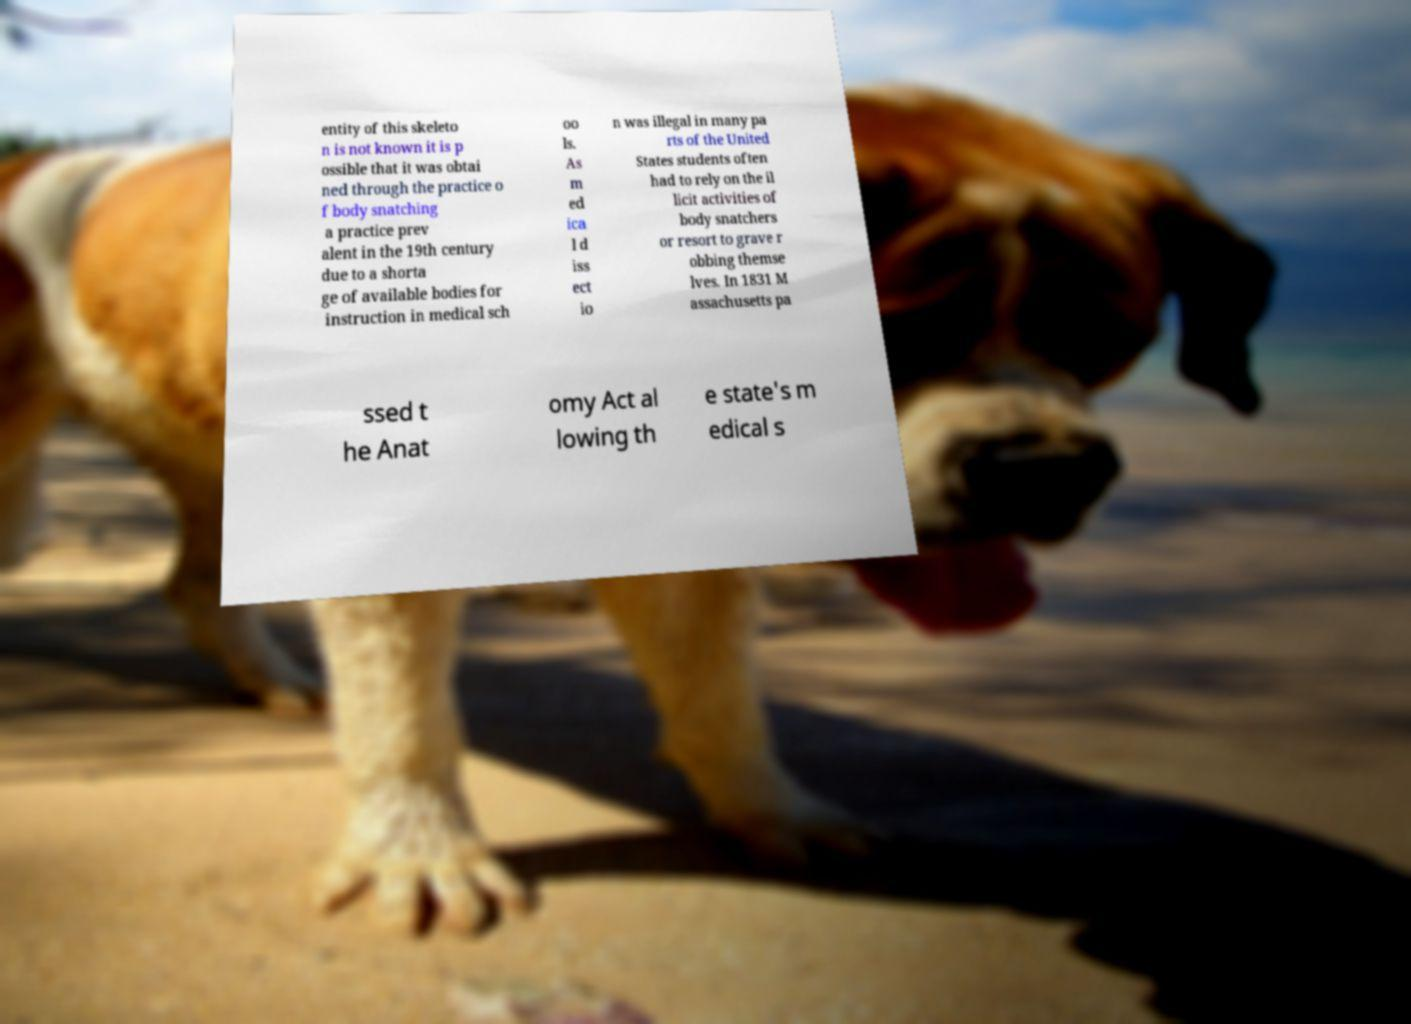Could you assist in decoding the text presented in this image and type it out clearly? entity of this skeleto n is not known it is p ossible that it was obtai ned through the practice o f body snatching a practice prev alent in the 19th century due to a shorta ge of available bodies for instruction in medical sch oo ls. As m ed ica l d iss ect io n was illegal in many pa rts of the United States students often had to rely on the il licit activities of body snatchers or resort to grave r obbing themse lves. In 1831 M assachusetts pa ssed t he Anat omy Act al lowing th e state's m edical s 